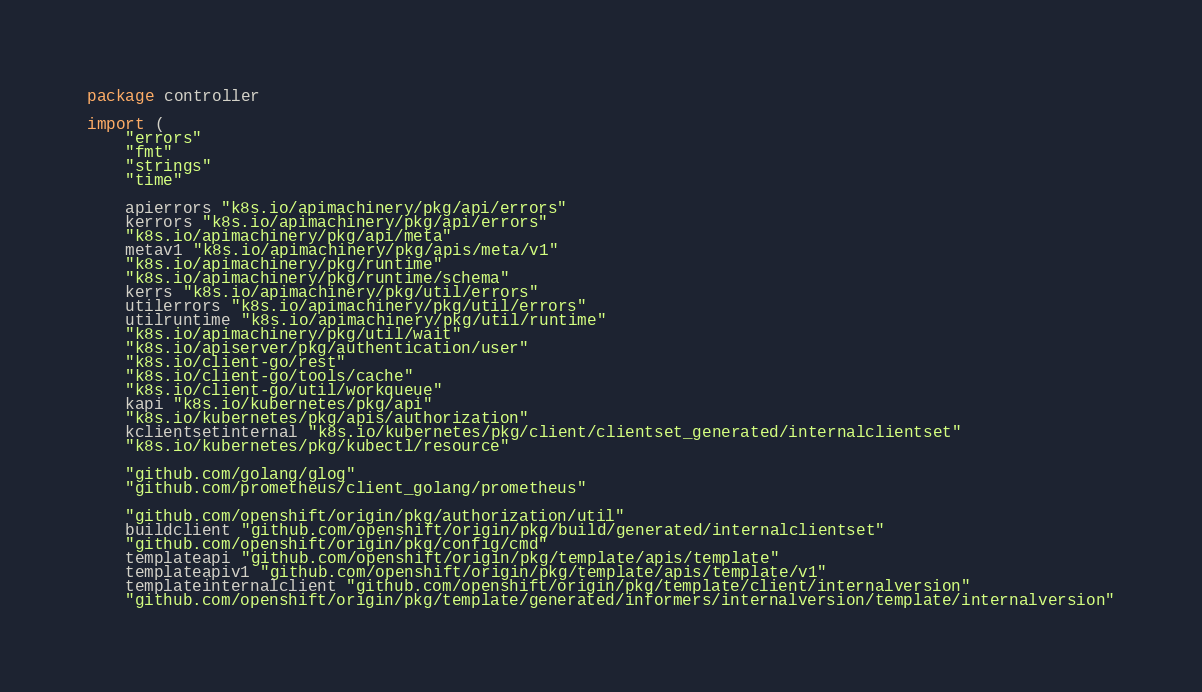Convert code to text. <code><loc_0><loc_0><loc_500><loc_500><_Go_>package controller

import (
	"errors"
	"fmt"
	"strings"
	"time"

	apierrors "k8s.io/apimachinery/pkg/api/errors"
	kerrors "k8s.io/apimachinery/pkg/api/errors"
	"k8s.io/apimachinery/pkg/api/meta"
	metav1 "k8s.io/apimachinery/pkg/apis/meta/v1"
	"k8s.io/apimachinery/pkg/runtime"
	"k8s.io/apimachinery/pkg/runtime/schema"
	kerrs "k8s.io/apimachinery/pkg/util/errors"
	utilerrors "k8s.io/apimachinery/pkg/util/errors"
	utilruntime "k8s.io/apimachinery/pkg/util/runtime"
	"k8s.io/apimachinery/pkg/util/wait"
	"k8s.io/apiserver/pkg/authentication/user"
	"k8s.io/client-go/rest"
	"k8s.io/client-go/tools/cache"
	"k8s.io/client-go/util/workqueue"
	kapi "k8s.io/kubernetes/pkg/api"
	"k8s.io/kubernetes/pkg/apis/authorization"
	kclientsetinternal "k8s.io/kubernetes/pkg/client/clientset_generated/internalclientset"
	"k8s.io/kubernetes/pkg/kubectl/resource"

	"github.com/golang/glog"
	"github.com/prometheus/client_golang/prometheus"

	"github.com/openshift/origin/pkg/authorization/util"
	buildclient "github.com/openshift/origin/pkg/build/generated/internalclientset"
	"github.com/openshift/origin/pkg/config/cmd"
	templateapi "github.com/openshift/origin/pkg/template/apis/template"
	templateapiv1 "github.com/openshift/origin/pkg/template/apis/template/v1"
	templateinternalclient "github.com/openshift/origin/pkg/template/client/internalversion"
	"github.com/openshift/origin/pkg/template/generated/informers/internalversion/template/internalversion"</code> 